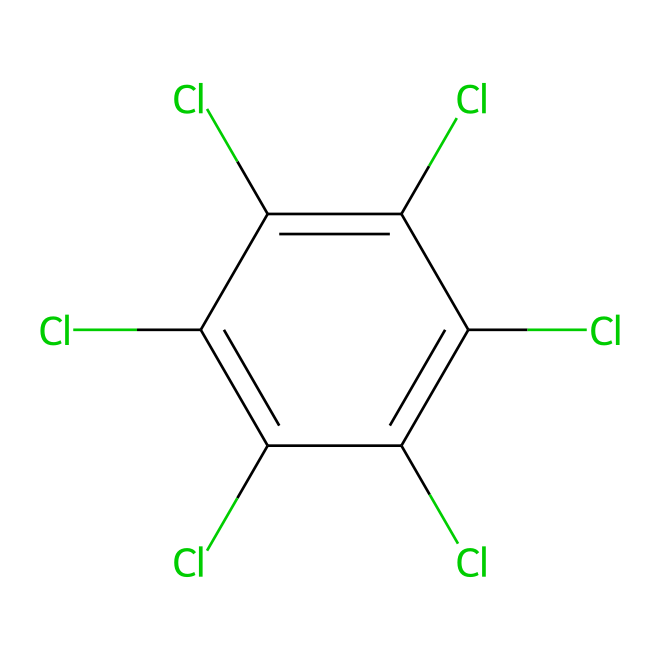What is the main functional group in chlorothalonil? The structure shows multiple chlorine (Cl) atoms attached to a carbon chain, indicating that it has halogen functional groups.
Answer: halogen How many chlorine atoms are present in chlorothalonil? By examining the structure, we can count six chlorine atoms attached to the carbon ring.
Answer: 6 What type of chemical structure does chlorothalonil exhibit? The presence of several aromatic carbon atoms indicates that chlorothalonil has an aromatic structure.
Answer: aromatic Is chlorothalonil a solid, liquid, or gas at room temperature? Typically, fungicides like chlorothalonil are solid at room temperature, as indicated by its chemical nature and common applications.
Answer: solid What is the molecular formula derived from the SMILES representation of chlorothalonil? By decoding the SMILES notation, we can determine the molecular formula as C8Cl6.
Answer: C8Cl6 What is the primary use of chlorothalonil? Chlorothalonil is primarily used as a fungicide in agriculture.
Answer: fungicide 